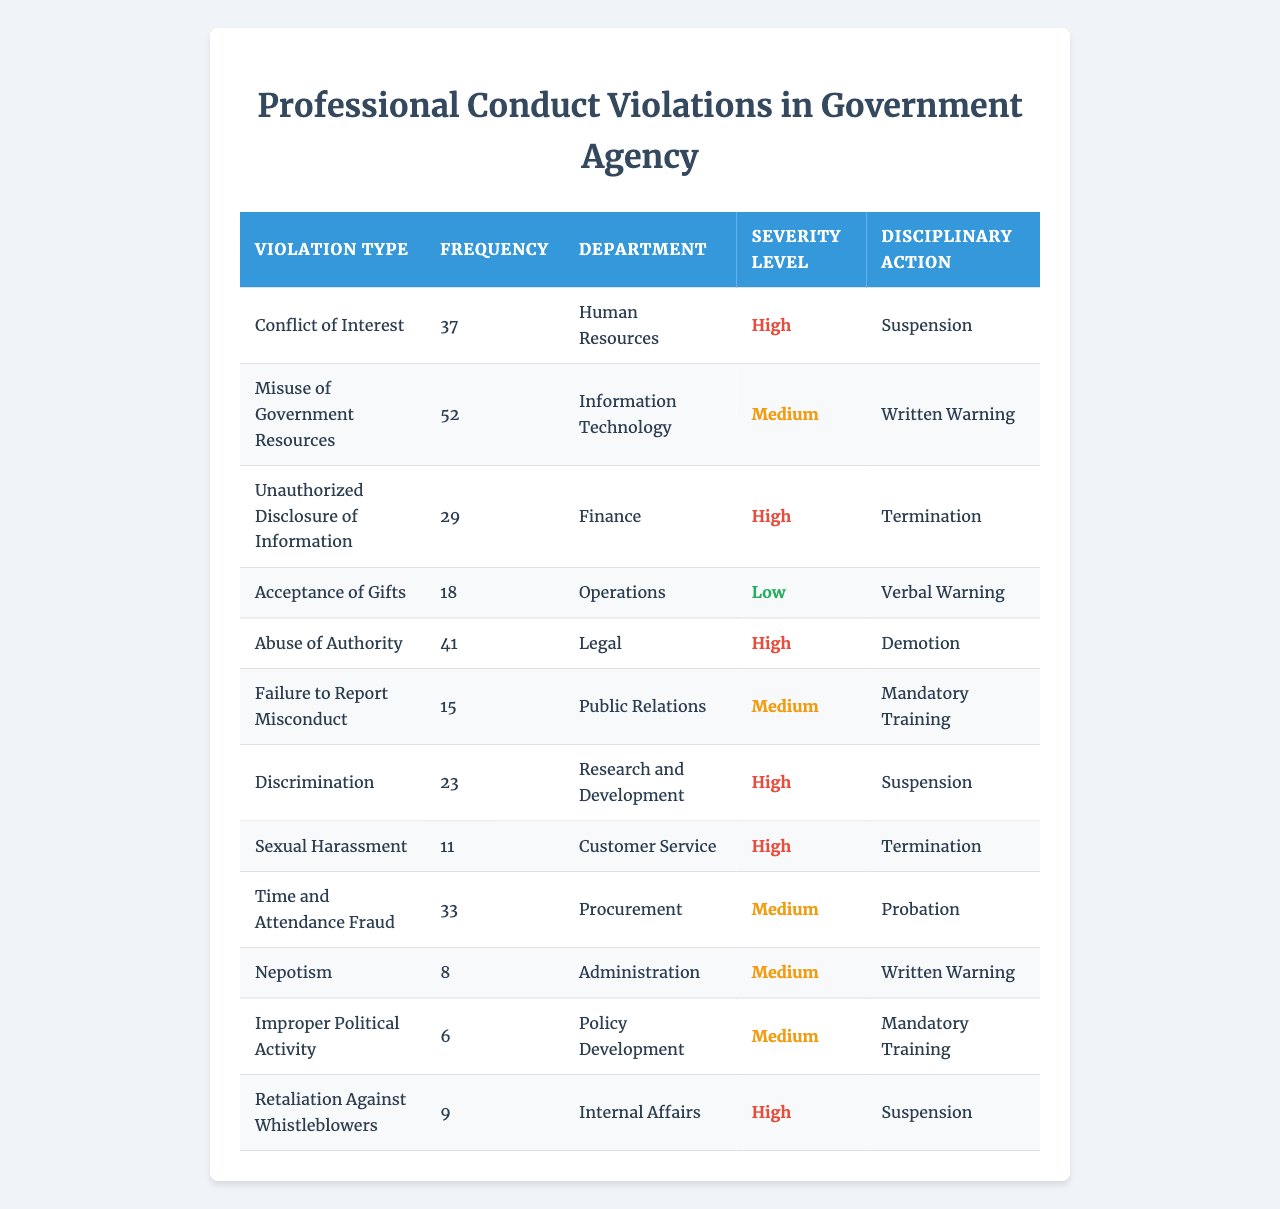What is the violation type with the highest frequency? The frequency of each violation type is listed in the table. By comparing the values, "Misuse of Government Resources" has the highest frequency at 52.
Answer: Misuse of Government Resources How many types of violations are categorized as 'High' severity? The table lists the severity levels for each violation type. Counting those marked as 'High', there are 6 instances: Conflict of Interest, Misuse of Government Resources, Abuse of Authority, Discrimination, Sexual Harassment, and Retaliation Against Whistleblowers.
Answer: 6 What is the total frequency of violations in the 'Human Resources' department? The table indicates that there is one violation type in the 'Human Resources' department with a frequency of 37. Hence, the total frequency is simply 37.
Answer: 37 Which violation type had the least frequency and what was the associated disciplinary action? From the table, 'Nepotism' has the least frequency recorded at 6, and the associated disciplinary action is "Mandatory Training".
Answer: Nepotism, Mandatory Training If we consider only the 'Medium' severity violations, what is their total frequency? The violations that are categorized as 'Medium' severity are: "Failure to Report Misconduct" (15), "Time and Attendance Fraud" (33), "Improper Political Activity" (6), and "Mandatory Training" (9). Adding these gives: 15 + 33 + 6 + 9 = 63.
Answer: 63 Is there any violation type that is both 'High' severity and associated with 'Termination' as the disciplinary action? Checking the table, we see that both 'Sexual Harassment' and 'Misuse of Government Resources' are high severity and linked to termination. Thus, the answer is yes.
Answer: Yes Which department has the most violations? By reviewing the table, the most frequent violations are from different departments. However, only the 'Finance' department is linked with just one violation. Thus, each department has one corresponding violation type, so no specific department has a majority in this case.
Answer: No department with most violations What is the average frequency of all recorded violations? To calculate the average, sum up all frequencies: (37 + 52 + 29 + 18 + 41 + 15 + 23 + 11 + 33 + 8 + 6 + 9) =  263. There are 12 violation types, so the average is 263 / 12 = 21.9167. Rounding gives approximately 22.
Answer: ~22 How many violations resulting in 'Suspension' are classified as 'High' severity? The table shows that the violations leading to 'Suspension' that are classified as 'High' severity include: "Conflict of Interest" (37) and "Sexual Harassment" (11). Therefore, there are a total of two such violations.
Answer: 2 What is the disciplinary action for the 'Acceptance of Gifts' violation type? The table indicates that 'Acceptance of Gifts' has a disciplinary action of "Verbal Warning".
Answer: Verbal Warning 